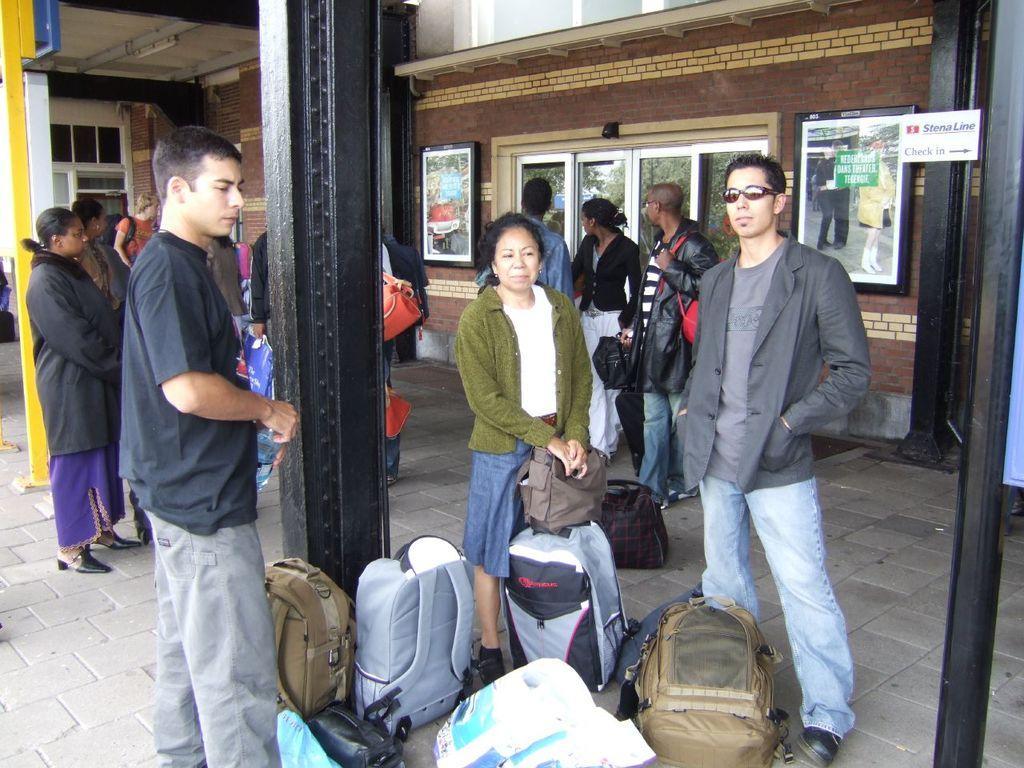Could you give a brief overview of what you see in this image? In this image in front there are bags. There are people standing on the platform. There are pillars. In the background of the image there are glass windows. There are photo frames attached to the wall. 